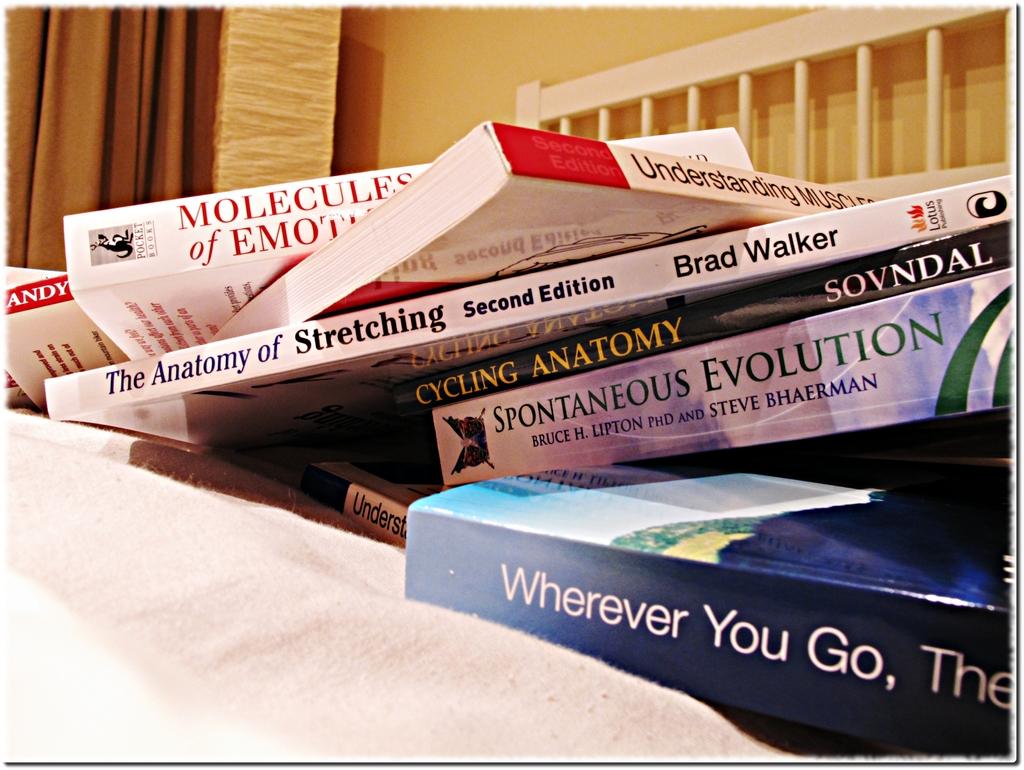Who wrote the anatomy of stretching?
Give a very brief answer. Brad walker. Which edition is the anatomy of stretching?
Ensure brevity in your answer.  Second. 